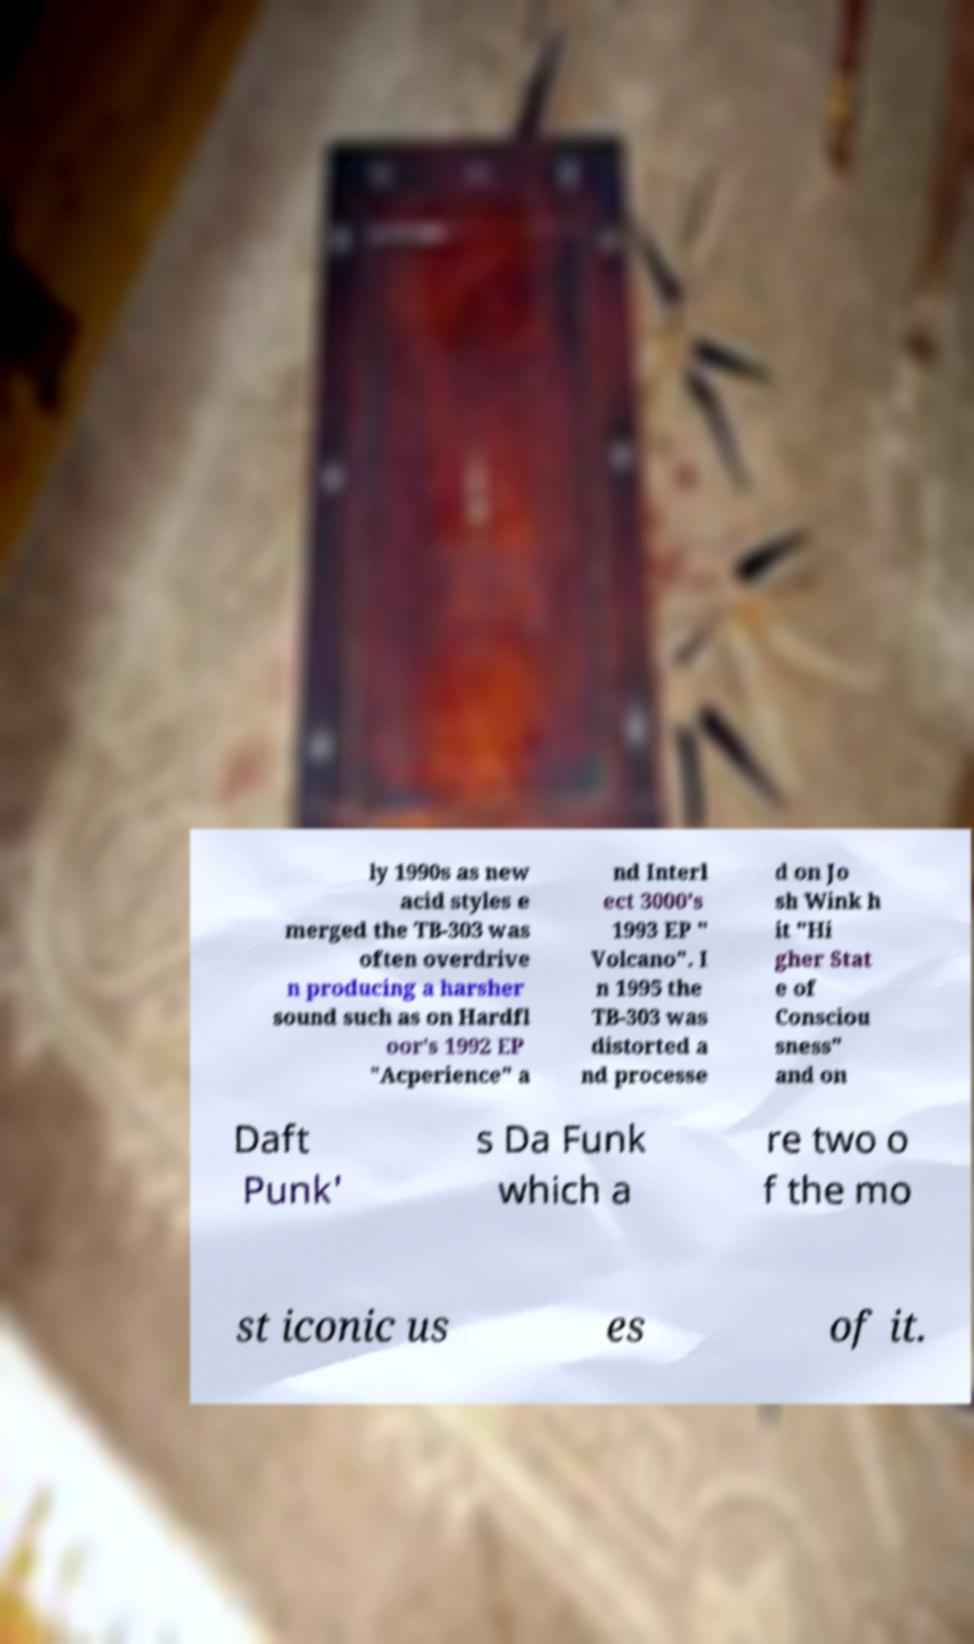Please read and relay the text visible in this image. What does it say? ly 1990s as new acid styles e merged the TB-303 was often overdrive n producing a harsher sound such as on Hardfl oor's 1992 EP "Acperience" a nd Interl ect 3000's 1993 EP " Volcano". I n 1995 the TB-303 was distorted a nd processe d on Jo sh Wink h it "Hi gher Stat e of Consciou sness" and on Daft Punk' s Da Funk which a re two o f the mo st iconic us es of it. 